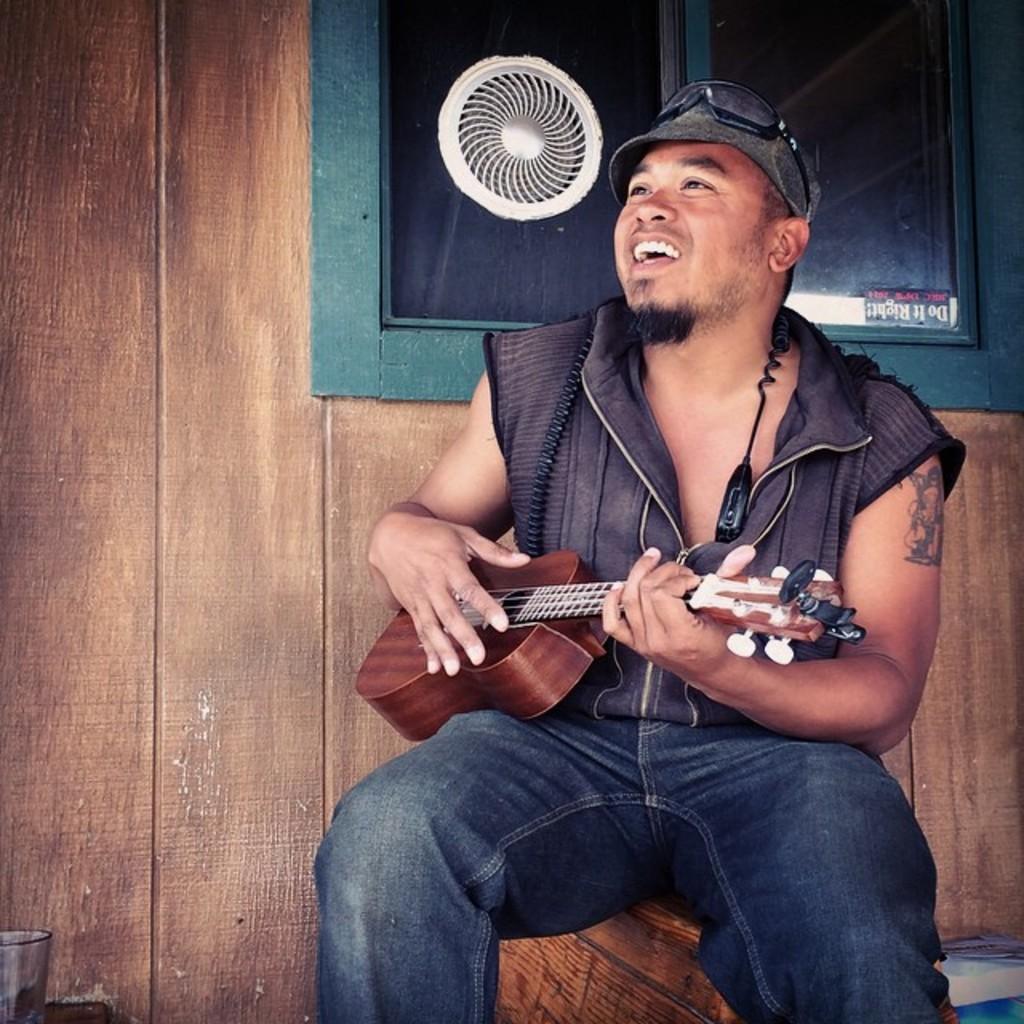Please provide a concise description of this image. In this picture there is a man, he is playing a guitar. He is wearing a jacket, hat and a blue jeans. In the background there is a wood wall and a window. 